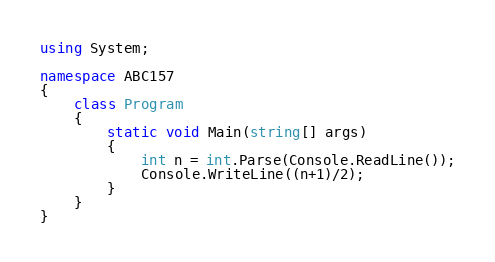<code> <loc_0><loc_0><loc_500><loc_500><_C#_>using System;

namespace ABC157
{
    class Program
    {
        static void Main(string[] args)
        {
            int n = int.Parse(Console.ReadLine());
            Console.WriteLine((n+1)/2);
        }
    }
}
</code> 